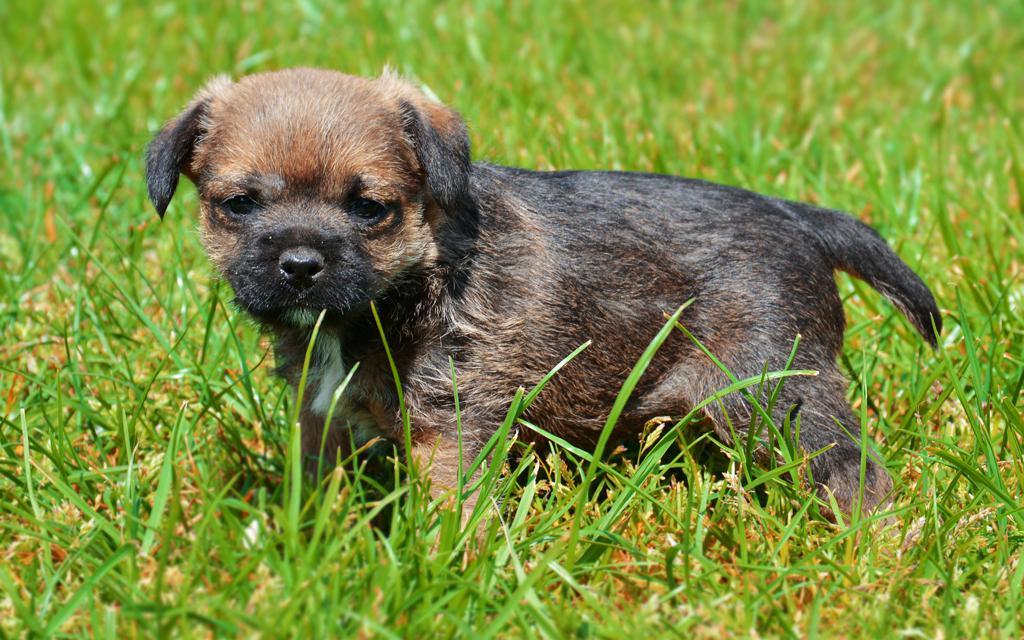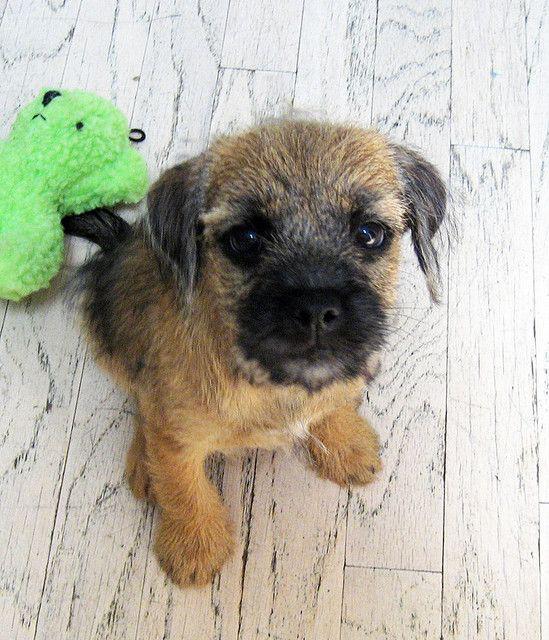The first image is the image on the left, the second image is the image on the right. For the images shown, is this caption "A dog posed outdoors is wearing something that buckles and extends around its neck." true? Answer yes or no. No. The first image is the image on the left, the second image is the image on the right. Examine the images to the left and right. Is the description "The dog in the image on the right is wearing a collar." accurate? Answer yes or no. No. 